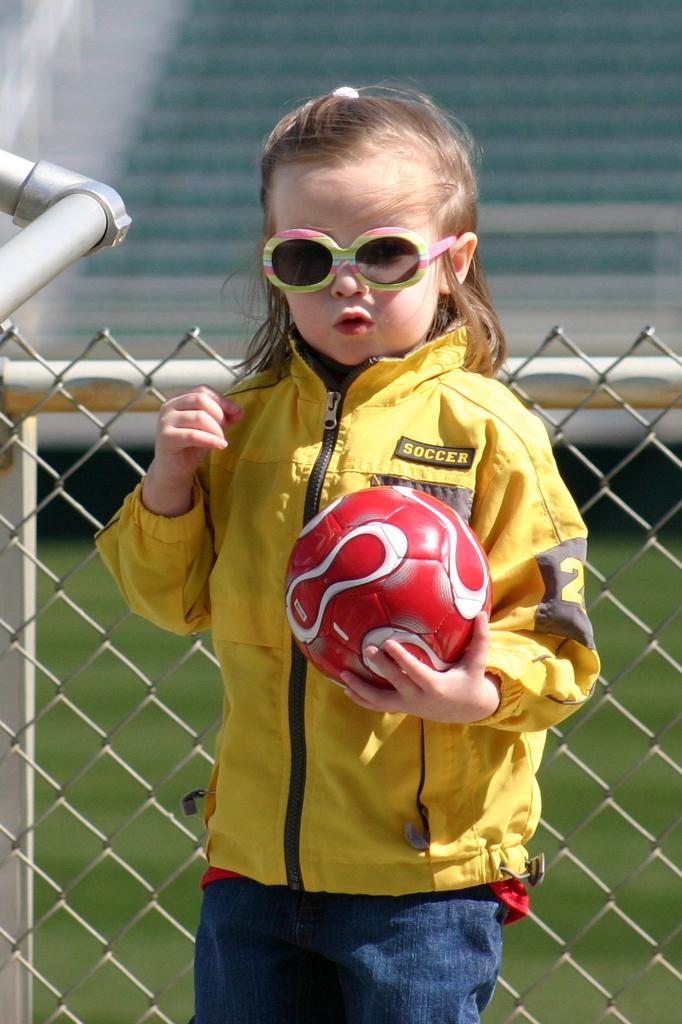What can be seen in the background of the image? There are stairs in the background of the image. Can you describe the girl in the image? The girl is wearing a yellow jacket and goggles, and she is holding a ball in her hand. What is the purpose of the net mesh behind the girl? The net mesh might be used for a sport or game, as it is located behind the girl who is holding a ball. What type of soup is the girl eating in the image? There is no soup present in the image; the girl is holding a ball and wearing a yellow jacket, goggles, and a net mesh is behind her. How does the girl feel about tying a knot in the image? There is no mention of a knot or any emotions related to it in the image. 